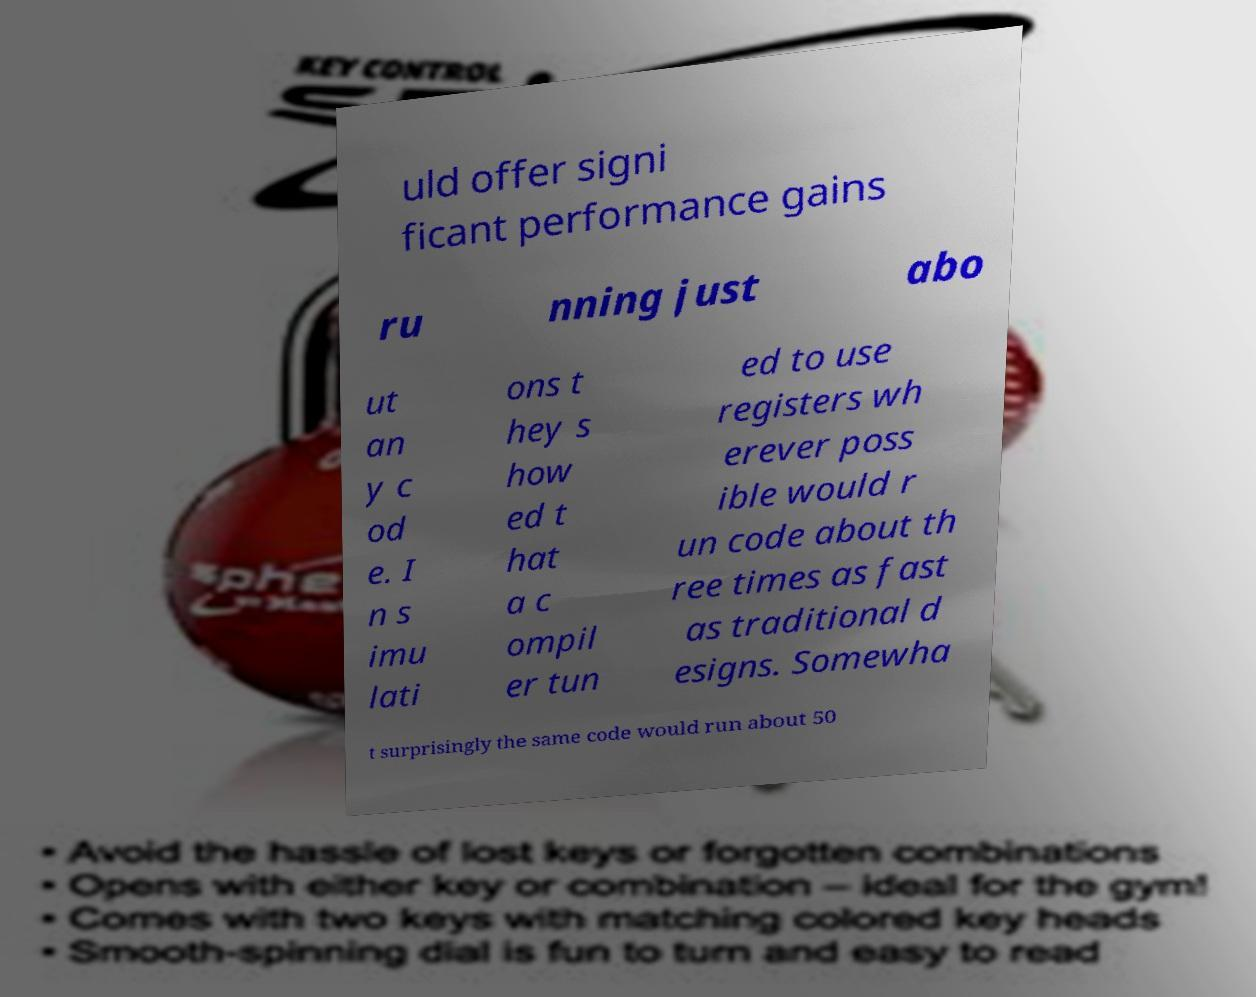Could you assist in decoding the text presented in this image and type it out clearly? uld offer signi ficant performance gains ru nning just abo ut an y c od e. I n s imu lati ons t hey s how ed t hat a c ompil er tun ed to use registers wh erever poss ible would r un code about th ree times as fast as traditional d esigns. Somewha t surprisingly the same code would run about 50 